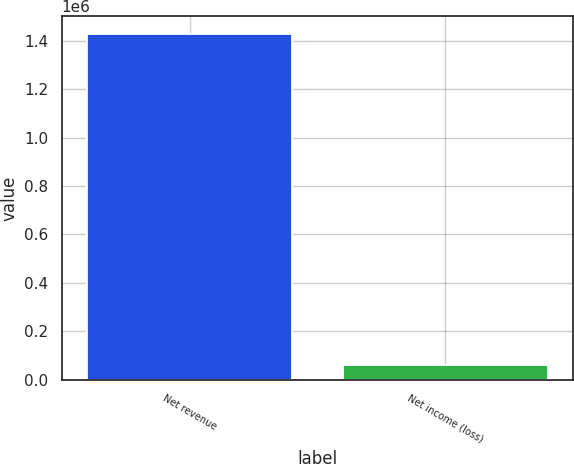<chart> <loc_0><loc_0><loc_500><loc_500><bar_chart><fcel>Net revenue<fcel>Net income (loss)<nl><fcel>1.42963e+06<fcel>61805<nl></chart> 